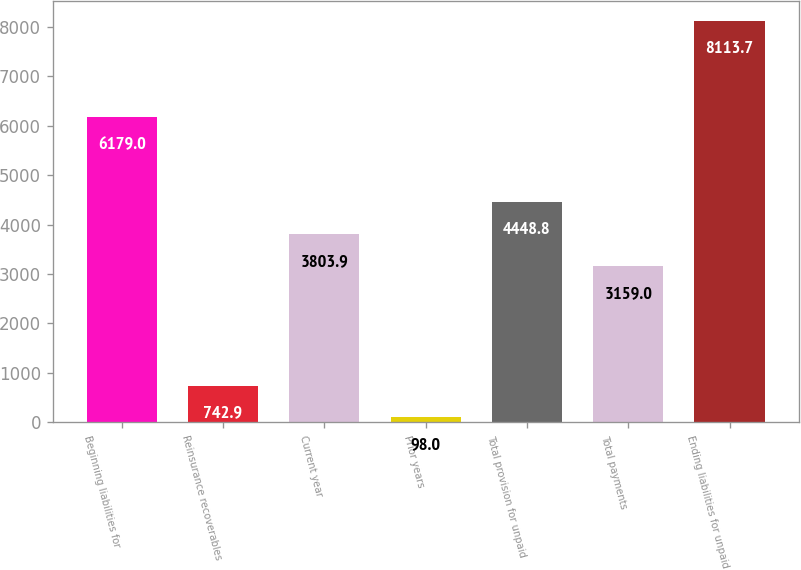Convert chart. <chart><loc_0><loc_0><loc_500><loc_500><bar_chart><fcel>Beginning liabilities for<fcel>Reinsurance recoverables<fcel>Current year<fcel>Prior years<fcel>Total provision for unpaid<fcel>Total payments<fcel>Ending liabilities for unpaid<nl><fcel>6179<fcel>742.9<fcel>3803.9<fcel>98<fcel>4448.8<fcel>3159<fcel>8113.7<nl></chart> 